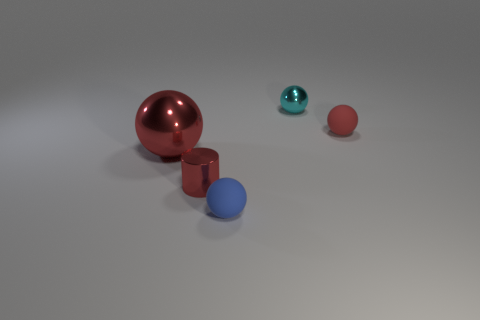How many small objects are the same color as the large metal ball?
Keep it short and to the point. 2. Are there any small metallic objects in front of the matte thing behind the thing to the left of the small cylinder?
Provide a succinct answer. Yes. What size is the red thing that is both on the right side of the big red object and behind the tiny cylinder?
Offer a terse response. Small. What number of small red balls are the same material as the red cylinder?
Your answer should be very brief. 0. What number of cubes are either small cyan metal things or big red metallic things?
Ensure brevity in your answer.  0. What size is the red sphere that is right of the matte object to the left of the red ball that is to the right of the small blue rubber ball?
Your answer should be compact. Small. There is a object that is behind the tiny blue matte object and in front of the large thing; what is its color?
Your response must be concise. Red. There is a red cylinder; does it have the same size as the metallic ball that is behind the red matte thing?
Your response must be concise. Yes. Is there any other thing that has the same shape as the large red thing?
Keep it short and to the point. Yes. The tiny metallic thing that is the same shape as the big red object is what color?
Your response must be concise. Cyan. 